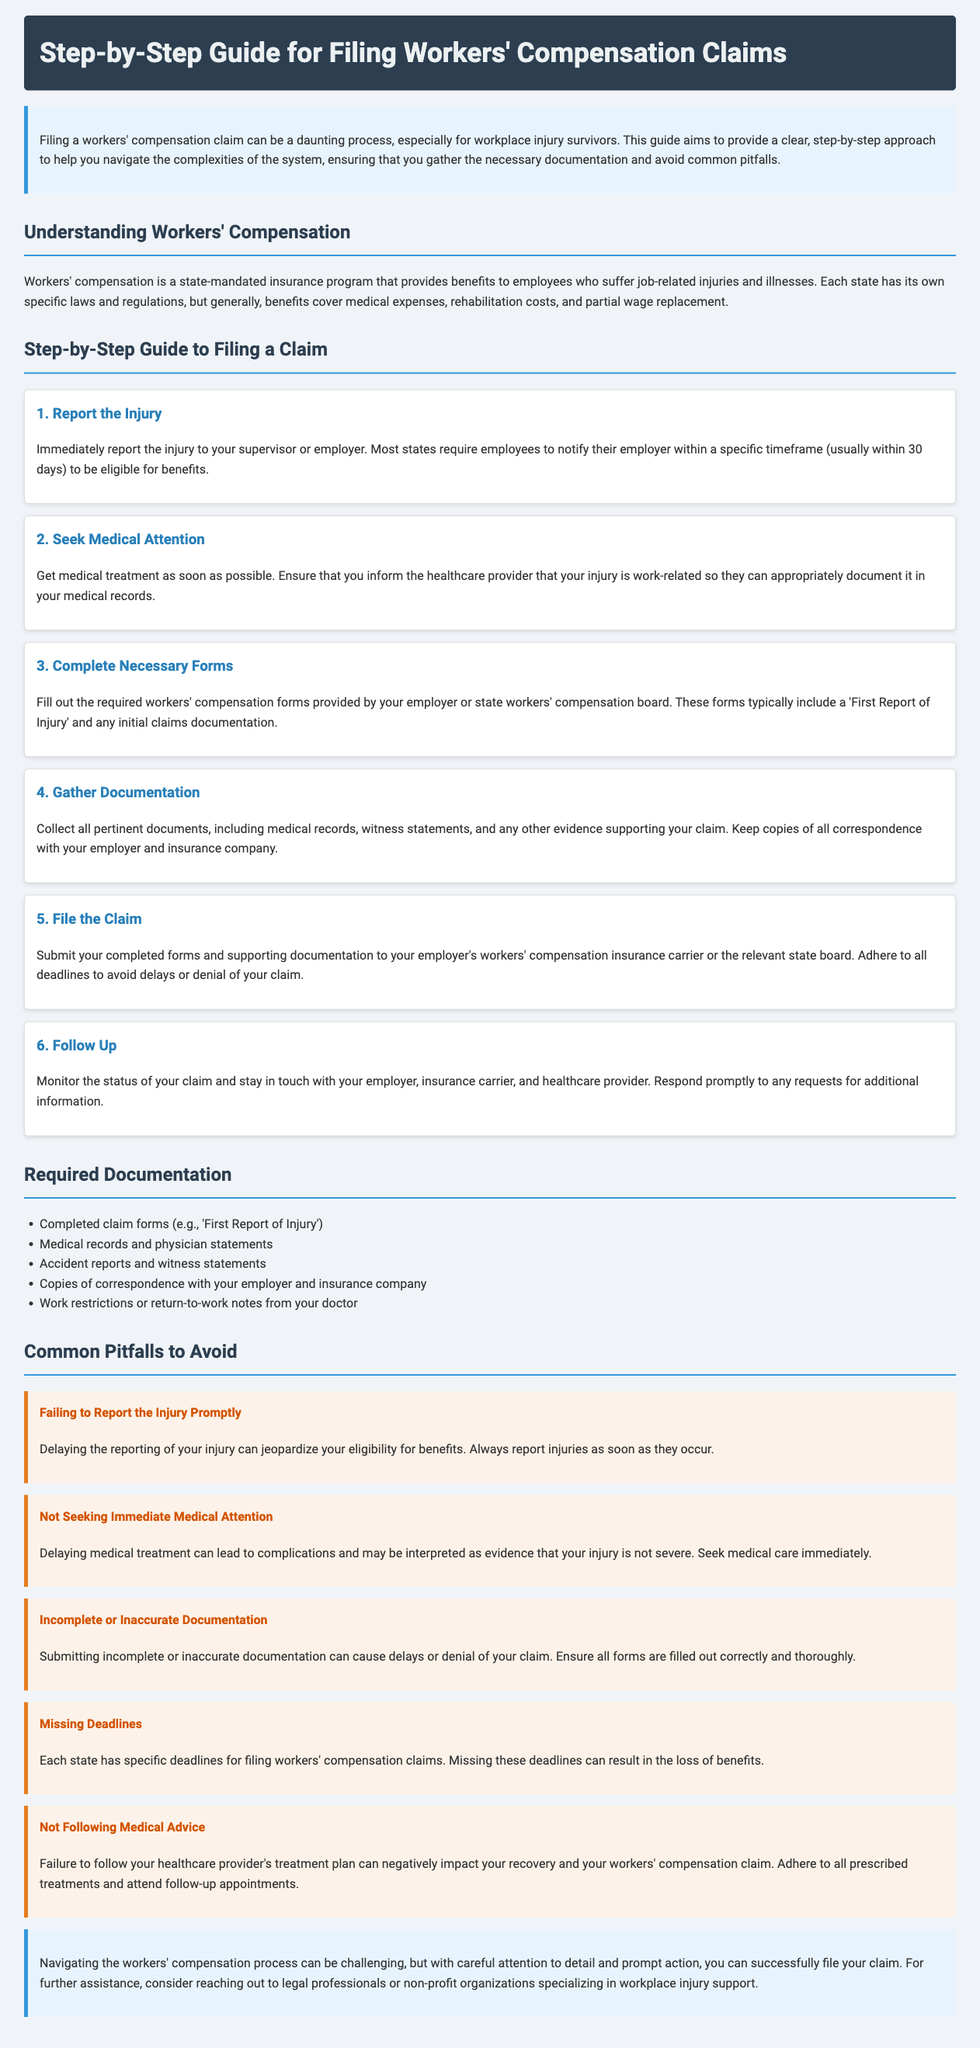What is the first step in filing a workers' compensation claim? The first step is to immediately report the injury to your supervisor or employer.
Answer: Report the Injury What is the time frame to report an injury to be eligible for benefits? Most states require employees to notify their employer within a specific timeframe, usually within 30 days.
Answer: 30 days What type of documentation must be gathered for a claim? Relevant documents that must be collected include medical records, witness statements, and evidence supporting the claim.
Answer: Medical records, witness statements What should be included in the required documentation? Required documentation includes completed claim forms, medical records, accident reports, and correspondence copies.
Answer: Completed claim forms, medical records, accident reports What is a common pitfall related to medical attention? A common pitfall is not seeking immediate medical attention after an injury occurs.
Answer: Not Seeking Immediate Medical Attention What is crucial to ensure when submitting documentation? It is crucial to submit complete and accurate documentation to avoid delays or denial of the claim.
Answer: Complete or Inaccurate Documentation What should you do after filing the claim? After filing the claim, you should monitor its status and stay in touch with relevant parties.
Answer: Follow Up What is the potential consequence of missing claim deadlines? Missing deadlines can result in the loss of benefits.
Answer: Loss of benefits 